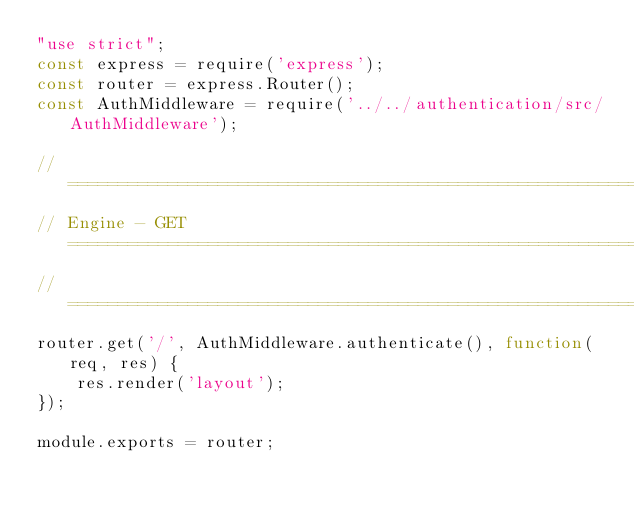Convert code to text. <code><loc_0><loc_0><loc_500><loc_500><_JavaScript_>"use strict";
const express = require('express');
const router = express.Router();
const AuthMiddleware = require('../../authentication/src/AuthMiddleware');

// =========================================================================
// Engine - GET ============================================================
// =========================================================================
router.get('/', AuthMiddleware.authenticate(), function(req, res) {
    res.render('layout');
});

module.exports = router;
</code> 